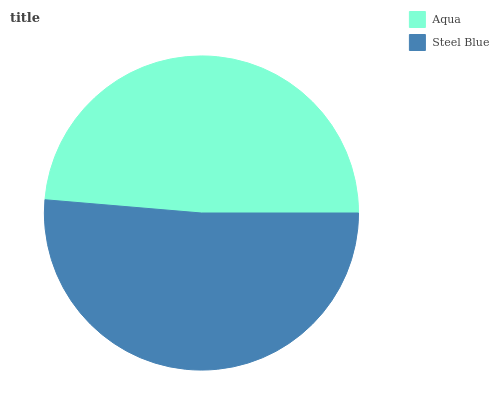Is Aqua the minimum?
Answer yes or no. Yes. Is Steel Blue the maximum?
Answer yes or no. Yes. Is Steel Blue the minimum?
Answer yes or no. No. Is Steel Blue greater than Aqua?
Answer yes or no. Yes. Is Aqua less than Steel Blue?
Answer yes or no. Yes. Is Aqua greater than Steel Blue?
Answer yes or no. No. Is Steel Blue less than Aqua?
Answer yes or no. No. Is Steel Blue the high median?
Answer yes or no. Yes. Is Aqua the low median?
Answer yes or no. Yes. Is Aqua the high median?
Answer yes or no. No. Is Steel Blue the low median?
Answer yes or no. No. 